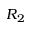<formula> <loc_0><loc_0><loc_500><loc_500>R _ { 2 }</formula> 